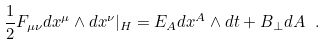<formula> <loc_0><loc_0><loc_500><loc_500>\frac { 1 } { 2 } F _ { \mu \nu } d x ^ { \mu } \wedge d x ^ { \nu } | _ { H } = E _ { A } d x ^ { A } \wedge d t + B _ { \perp } d A \ .</formula> 